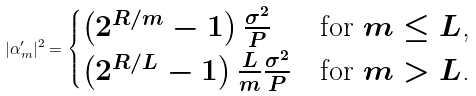Convert formula to latex. <formula><loc_0><loc_0><loc_500><loc_500>| \alpha ^ { \prime } _ { m } | ^ { 2 } = \begin{cases} \left ( 2 ^ { R / m } - 1 \right ) \frac { \sigma ^ { 2 } } { P } & \text {for $m\leq L$,} \\ \left ( 2 ^ { R / L } - 1 \right ) \frac { L } { m } \frac { \sigma ^ { 2 } } { P } & \text {for $m>L$.} \end{cases}</formula> 